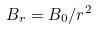<formula> <loc_0><loc_0><loc_500><loc_500>B _ { r } = B _ { 0 } / r ^ { 2 }</formula> 